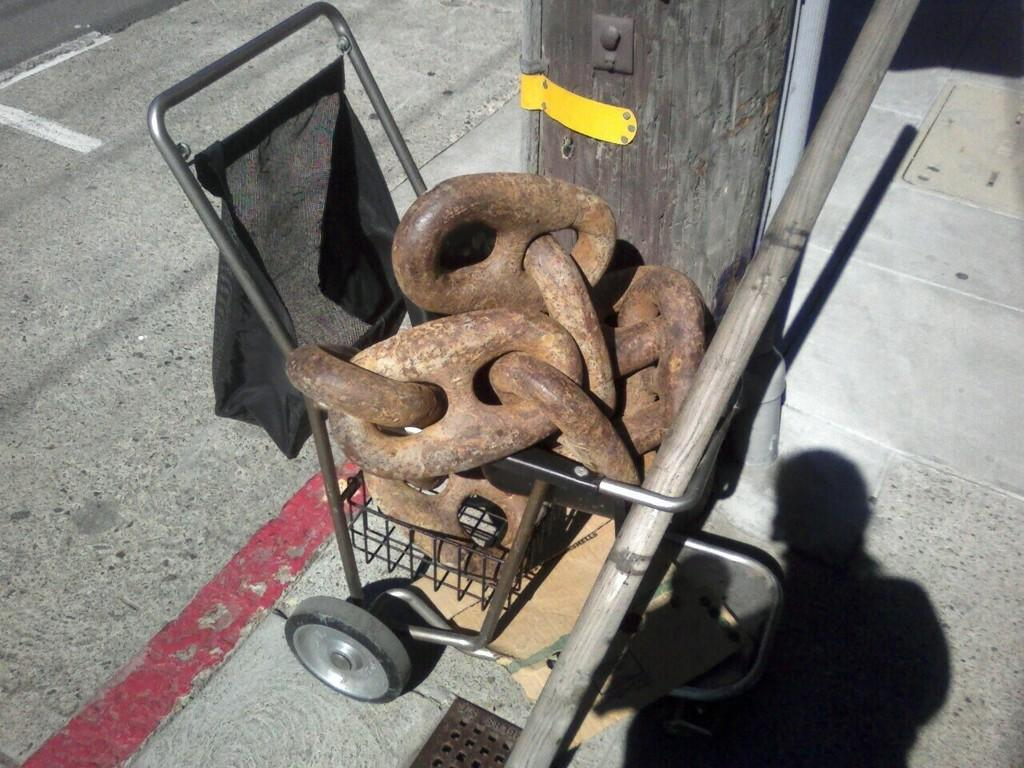What is being transported in the trolley in the image? The facts do not specify what objects are in the trolley. What musical instrument can be seen in the image? There is a black bagpipe in the image. What architectural feature is present in the image? There is a pillar in the image. What type of pathway is visible in the image? There is a walkway in the image. What can be seen on the right side bottom of the image? There is a human shadow on the right side bottom of the image. What cooking appliance is present in the image? There is a grill in the image. How many doors are visible in the image? There is no mention of doors in the image; only a trolley, a black bagpipe, a pillar, a walkway, a human shadow, and a grill are mentioned. What type of window can be seen in the image? There is no mention of windows in the image; only a trolley, a black bagpipe, a pillar, a walkway, a human shadow, and a grill are mentioned. 